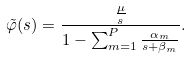Convert formula to latex. <formula><loc_0><loc_0><loc_500><loc_500>\tilde { \varphi } ( s ) = \frac { \frac { \mu } { s } } { 1 - \sum _ { m = 1 } ^ { P } \frac { \alpha _ { m } } { s + \beta _ { m } } } .</formula> 